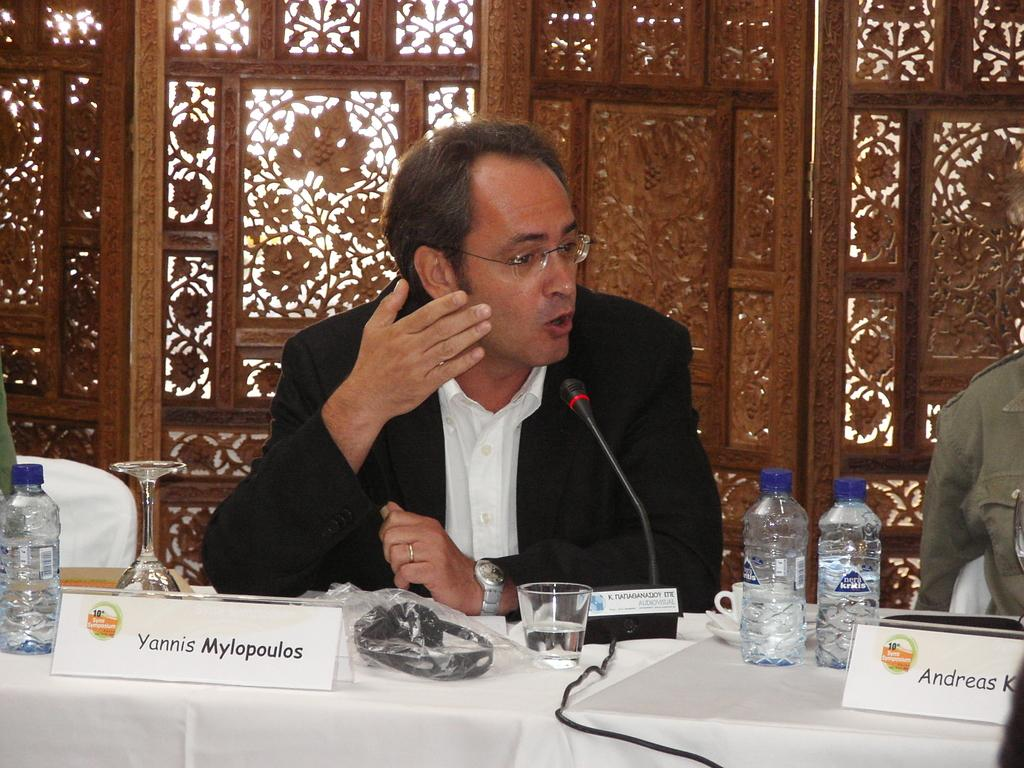What is the man in the image doing? The man is sitting and talking in front of a microphone. What objects are on the table in the image? There are three bottles, a glass, and a board on the table. What can be seen in the background of the image? There is a wooden wall in the background. What type of business is being conducted in the hospital in the image? There is no hospital or business present in the image; it features a man talking in front of a microphone with objects on a table and a wooden wall in the background. 